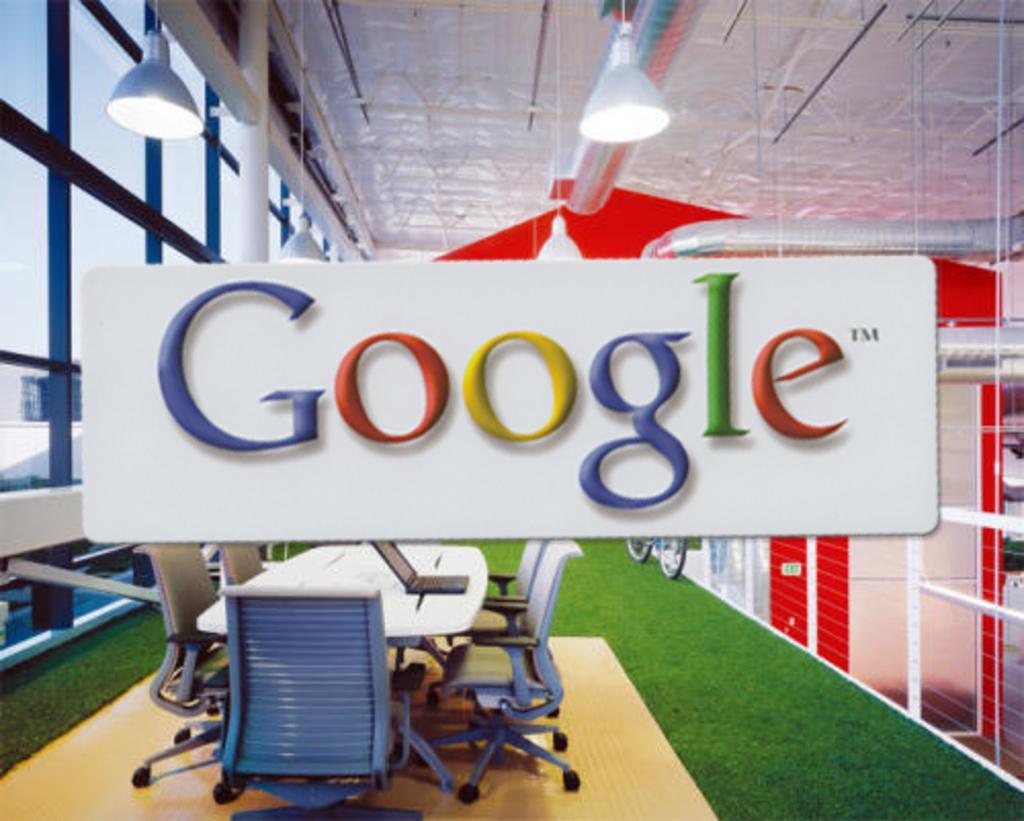Please provide a concise description of this image. In this picture we can see in side of the building, we can see some text and some chairs, table are arranged. 